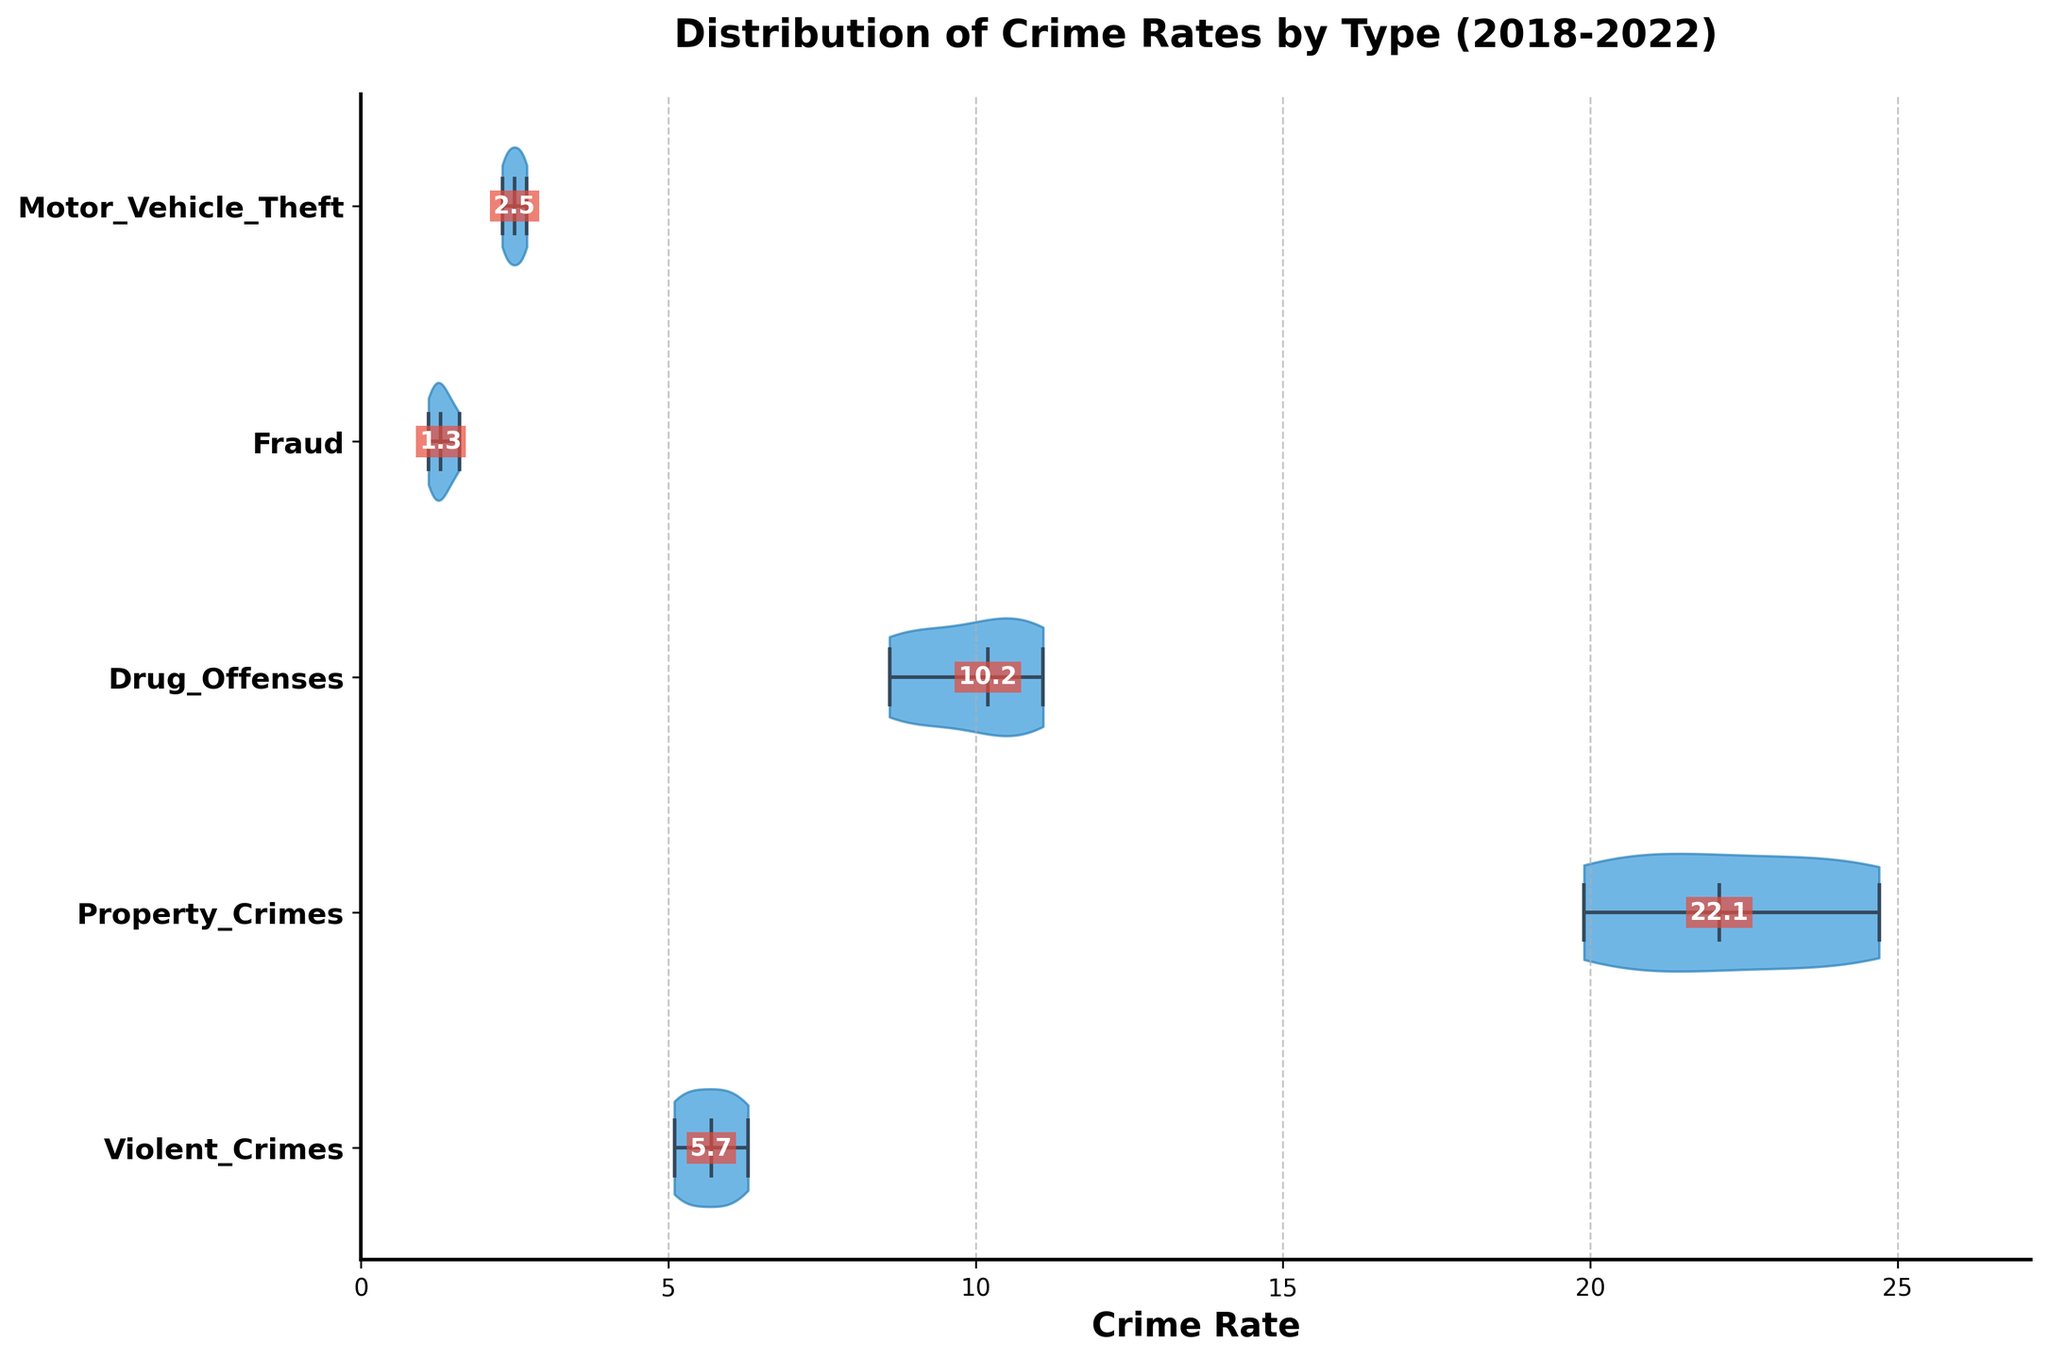What is the title of the chart? The title of the chart is usually displayed at the top of the figure, summarizing its content. In this case, the title is "Distribution of Crime Rates by Type (2018-2022)."
Answer: Distribution of Crime Rates by Type (2018-2022) What are the types of crime represented in the chart? The types of crime are labeled on the y-axis of the violin plot. From top to bottom, they are Violent Crimes, Property Crimes, Drug Offenses, Fraud, and Motor Vehicle Theft.
Answer: Violent Crimes, Property Crimes, Drug Offenses, Fraud, Motor Vehicle Theft Which crime type has the highest median crime rate? To identify the highest median, look for the median markers (usually a central line within the violin) of different crime types. The crime type with the highest median marker is Drug Offenses.
Answer: Drug Offenses What is the median crime rate for Violent Crimes? The median crime rate is marked by the central line inside the "Violent Crimes" violin. The text annotation displays this value as 6.0.
Answer: 6.0 How does the crime rate distribution for Property Crimes compare to that for Motor Vehicle Theft? The width of the violins indicates the spread of the data. Property Crimes show a much wider distribution compared to Motor Vehicle Theft, indicating a broader range of rates. Meanwhile, Motor Vehicle Theft displays a narrower range.
Answer: Property Crimes have a wider distribution, indicating a broader range of rates What is the range of crime rates for Drug Offenses? The range can be estimated by observing the top and bottom extents of the respective violin plot. For Drug Offenses, this range spans from approximately 8.6 to 11.1.
Answer: 8.6 to 11.1 Which crime type shows the narrowest distribution of rates? The narrowest distribution is indicated by the violin that is less wide. Fraud shows the narrowest distribution of rates.
Answer: Fraud How do the median crime rates for Property Crimes and Violent Crimes differ? The difference in medians can be observed directly from the chart. For Property Crimes, the median is around 19.9, and for Violent Crimes, it is 6.0. The difference is 19.9 - 6.0.
Answer: 13.9 Which crime type has the lowest median crime rate? The lowest median rate is observed by identifying the lowest central line within the violins. Fraud has the lowest median crime rate, as marked textually.
Answer: Fraud What is the general trend for crime rates from Violent Crimes and Drug Offenses over the years? The trend can be assessed by observing how the median shifts over different years. For Violent Crimes, the rate generally increases, and for Drug Offenses, it also shows an upward trend in later years, as seen by the medians gradually rising.
Answer: Increasing 